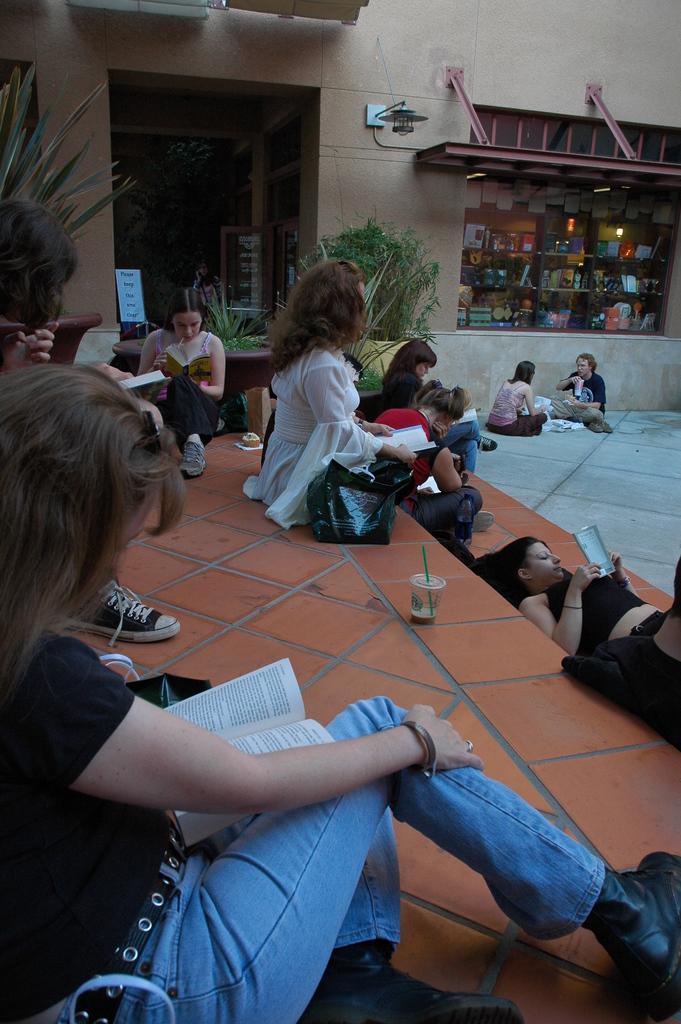Describe this image in one or two sentences. In the image we can see there are people sitting and one is lying, they are wearing clothes and shoes. Here we can see the books, plants and floor. It looks like the building and the shop. 